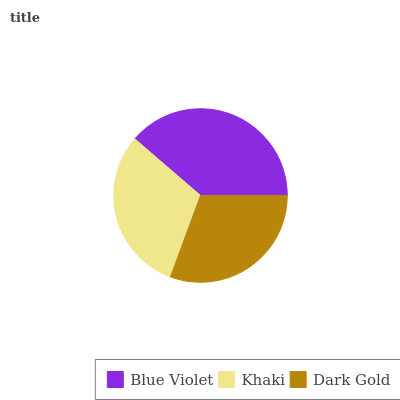Is Dark Gold the minimum?
Answer yes or no. Yes. Is Blue Violet the maximum?
Answer yes or no. Yes. Is Khaki the minimum?
Answer yes or no. No. Is Khaki the maximum?
Answer yes or no. No. Is Blue Violet greater than Khaki?
Answer yes or no. Yes. Is Khaki less than Blue Violet?
Answer yes or no. Yes. Is Khaki greater than Blue Violet?
Answer yes or no. No. Is Blue Violet less than Khaki?
Answer yes or no. No. Is Khaki the high median?
Answer yes or no. Yes. Is Khaki the low median?
Answer yes or no. Yes. Is Blue Violet the high median?
Answer yes or no. No. Is Dark Gold the low median?
Answer yes or no. No. 